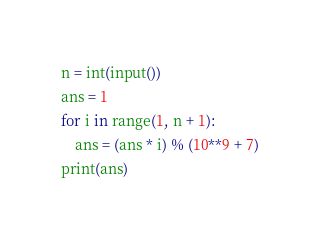Convert code to text. <code><loc_0><loc_0><loc_500><loc_500><_Python_>n = int(input())
ans = 1
for i in range(1, n + 1):
    ans = (ans * i) % (10**9 + 7)
print(ans)</code> 